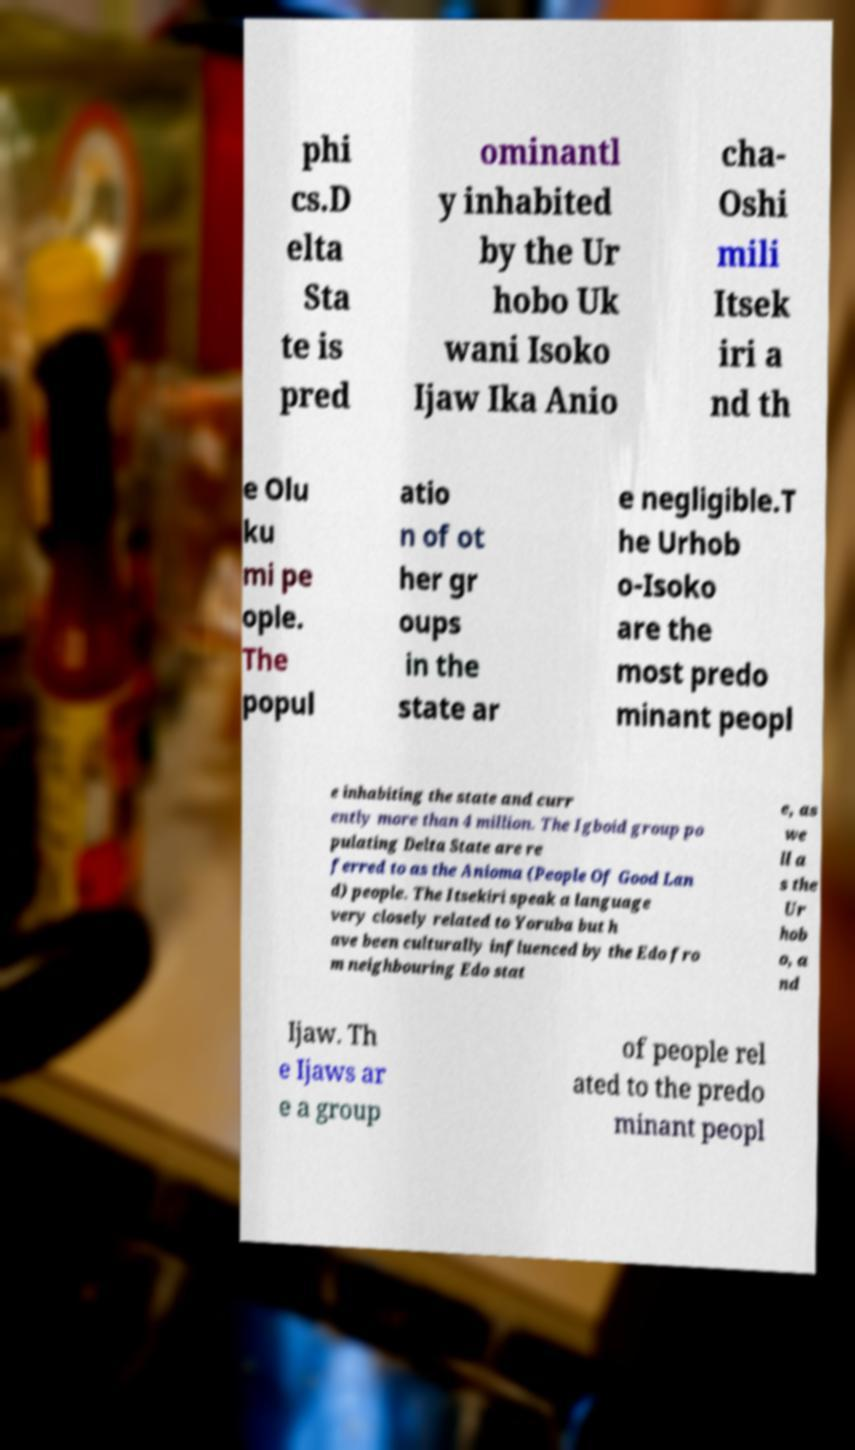What messages or text are displayed in this image? I need them in a readable, typed format. phi cs.D elta Sta te is pred ominantl y inhabited by the Ur hobo Uk wani Isoko Ijaw Ika Anio cha- Oshi mili Itsek iri a nd th e Olu ku mi pe ople. The popul atio n of ot her gr oups in the state ar e negligible.T he Urhob o-Isoko are the most predo minant peopl e inhabiting the state and curr ently more than 4 million. The Igboid group po pulating Delta State are re ferred to as the Anioma (People Of Good Lan d) people. The Itsekiri speak a language very closely related to Yoruba but h ave been culturally influenced by the Edo fro m neighbouring Edo stat e, as we ll a s the Ur hob o, a nd Ijaw. Th e Ijaws ar e a group of people rel ated to the predo minant peopl 